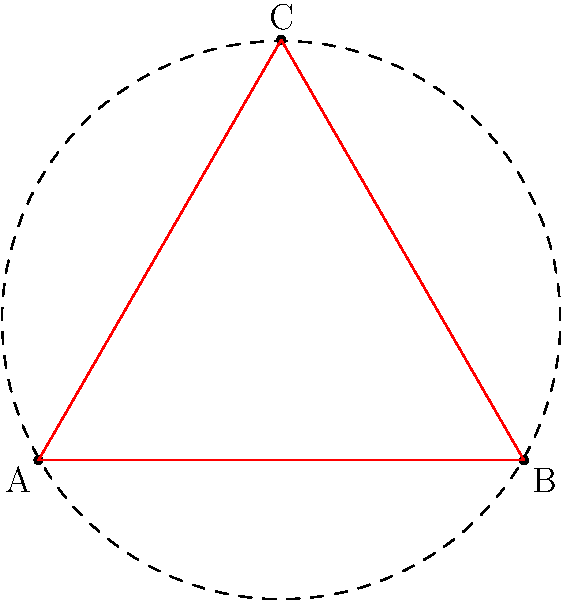Consider the equilateral triangle ABC and its rotational symmetries shown in the diagram. The blue and red triangles represent 120° and 240° rotations, respectively. How many distinct orbits are there under the action of the rotation group on the vertices of the triangle? Explain your reasoning in terms of group theory and symmetry operations. To solve this problem, let's follow these steps:

1) First, recall that the rotation group of an equilateral triangle is isomorphic to the cyclic group $C_3$, which consists of rotations by 0°, 120°, and 240°.

2) The group action we're considering is this rotation group acting on the set of vertices {A, B, C}.

3) An orbit of a vertex under this action is the set of all vertices that can be reached by applying the rotations to that vertex.

4) Let's consider the orbit of vertex A:
   - 0° rotation: A stays at A
   - 120° rotation: A moves to B
   - 240° rotation: A moves to C

5) We see that the orbit of A includes all vertices: {A, B, C}.

6) Due to the symmetry of the triangle, the orbits of B and C will also be {A, B, C}.

7) In group theory terms, we say that this action is transitive, meaning there is only one orbit containing all elements of the set.

Therefore, there is only one distinct orbit under this group action.
Answer: 1 orbit 